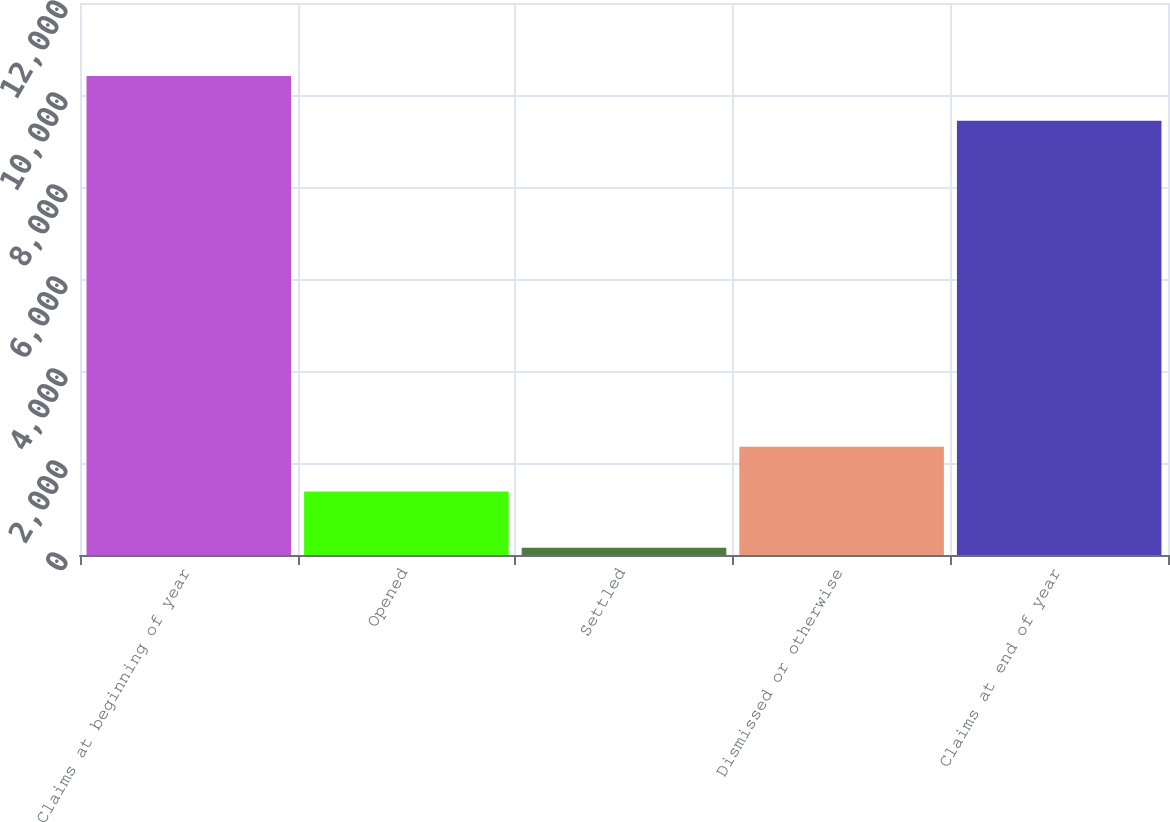Convert chart to OTSL. <chart><loc_0><loc_0><loc_500><loc_500><bar_chart><fcel>Claims at beginning of year<fcel>Opened<fcel>Settled<fcel>Dismissed or otherwise<fcel>Claims at end of year<nl><fcel>10413.8<fcel>1383<fcel>155<fcel>2354.8<fcel>9442<nl></chart> 